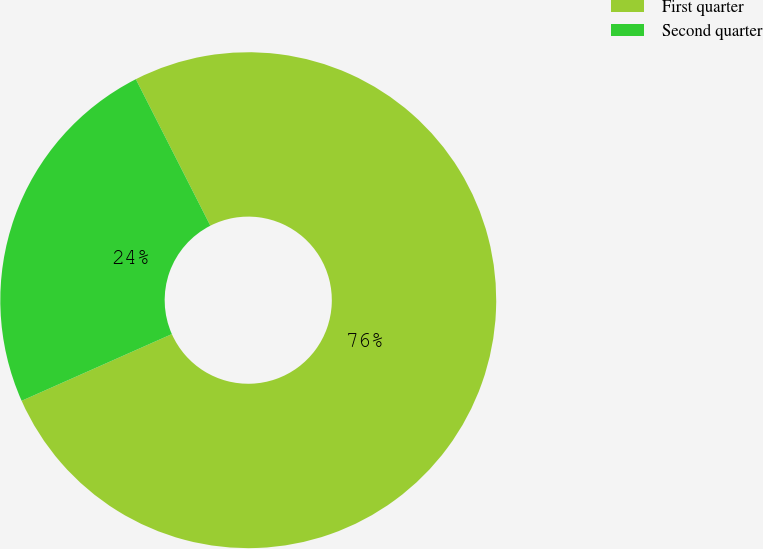Convert chart to OTSL. <chart><loc_0><loc_0><loc_500><loc_500><pie_chart><fcel>First quarter<fcel>Second quarter<nl><fcel>75.84%<fcel>24.16%<nl></chart> 